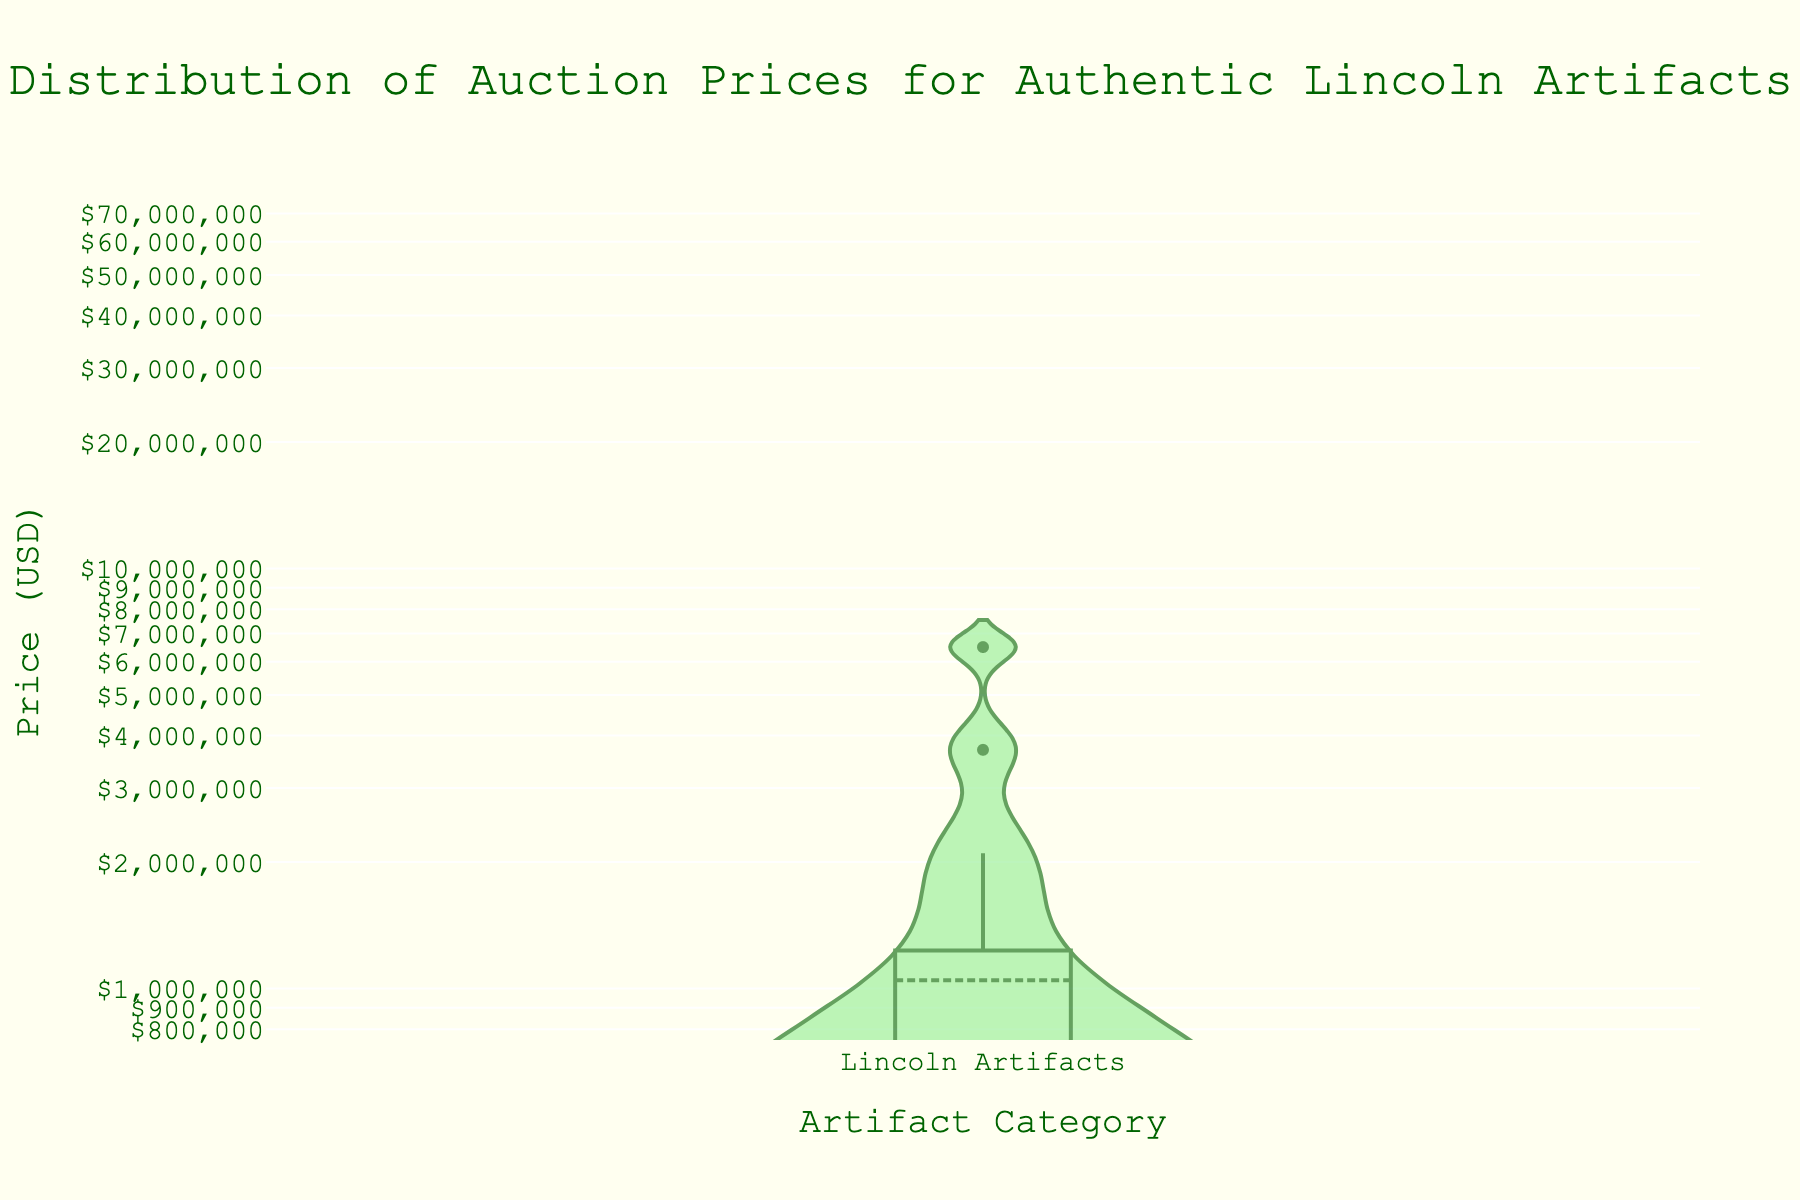What's the title of the figure? The title is placed at the top center of the figure, typically in a larger and bold font.
Answer: Distribution of Auction Prices for Authentic Lincoln Artifacts What does the Y-axis represent? The label of the Y-axis is usually found on the vertical axis and indicates what the values represent.
Answer: Price (USD) Which artifact has the highest auction price? The highest price is highlighted in the plot with an annotation marking the maximum value.
Answer: Lincoln's Hat What is the minimum auction price and for which artifact? The minimum price is annotated in the plot, showing both the value and the associated artifact.
Answer: $7,500, Lincoln Campaign Button Are the data points closer to each other at the lower or higher price range? Density plots show concentration through the spread of values; a closer clustering indicates higher density.
Answer: Lower price range How does the price of Lincoln's Hat compare to the average auction price? Determine the average auction price, then compare it with the value of Lincoln's Hat. First, calculate the average by summing all prices and dividing by the number of artifacts. Lincoln's Hat's price ($6,500,000) is compared to this result.
Answer: Lincoln's Hat is much higher than the average Is there a significant difference between the highest and lowest auction prices? Find the difference by subtracting the minimum price from the maximum price and evaluate the magnitude.
Answer: Yes, very significant Which artifact category appears on the X-axis? Check the X-axis label to identify which category of data is plotted.
Answer: Lincoln Artifacts Is the distribution of prices symmetrical? Analyze the density plot to see if it has mirrored or similarly shaped spreads on either side of a center point.
Answer: No What is the approximate mean auction price for the artifacts? Calculate the mean by summing all the prices and dividing by the total number of items. The graph provides average lines and may assist in the visual estimation.
Answer: Approximately $1,000,000 - $1,500,000 